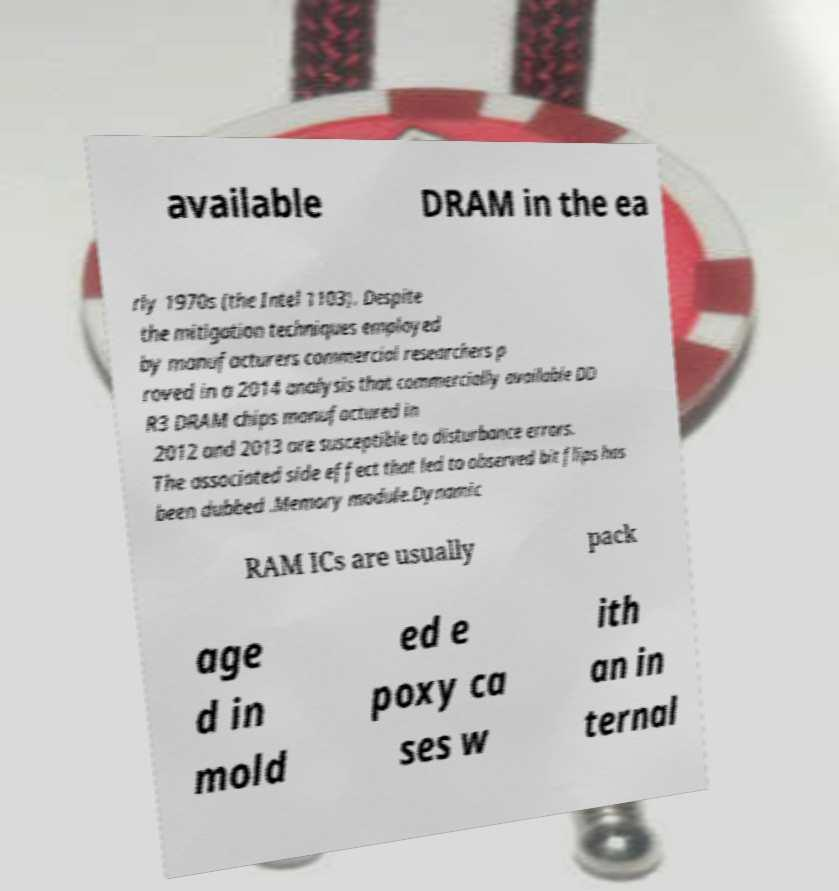Can you accurately transcribe the text from the provided image for me? available DRAM in the ea rly 1970s (the Intel 1103). Despite the mitigation techniques employed by manufacturers commercial researchers p roved in a 2014 analysis that commercially available DD R3 DRAM chips manufactured in 2012 and 2013 are susceptible to disturbance errors. The associated side effect that led to observed bit flips has been dubbed .Memory module.Dynamic RAM ICs are usually pack age d in mold ed e poxy ca ses w ith an in ternal 